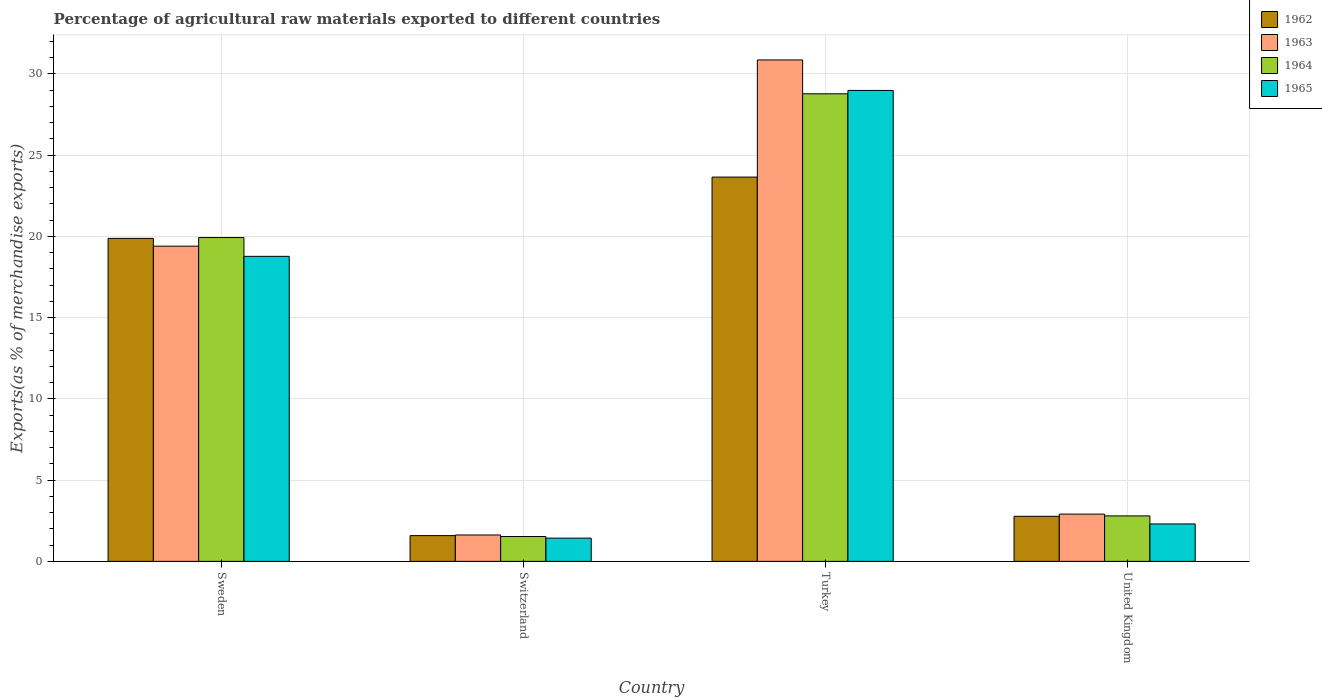How many groups of bars are there?
Ensure brevity in your answer.  4. What is the label of the 2nd group of bars from the left?
Offer a very short reply. Switzerland. What is the percentage of exports to different countries in 1964 in Switzerland?
Ensure brevity in your answer.  1.53. Across all countries, what is the maximum percentage of exports to different countries in 1965?
Provide a succinct answer. 28.99. Across all countries, what is the minimum percentage of exports to different countries in 1965?
Your answer should be compact. 1.43. In which country was the percentage of exports to different countries in 1964 minimum?
Your answer should be very brief. Switzerland. What is the total percentage of exports to different countries in 1962 in the graph?
Give a very brief answer. 47.89. What is the difference between the percentage of exports to different countries in 1963 in Sweden and that in Switzerland?
Ensure brevity in your answer.  17.78. What is the difference between the percentage of exports to different countries in 1965 in Turkey and the percentage of exports to different countries in 1962 in United Kingdom?
Give a very brief answer. 26.21. What is the average percentage of exports to different countries in 1964 per country?
Make the answer very short. 13.26. What is the difference between the percentage of exports to different countries of/in 1963 and percentage of exports to different countries of/in 1964 in Switzerland?
Provide a short and direct response. 0.1. In how many countries, is the percentage of exports to different countries in 1963 greater than 26 %?
Your answer should be compact. 1. What is the ratio of the percentage of exports to different countries in 1963 in Sweden to that in United Kingdom?
Offer a very short reply. 6.67. Is the percentage of exports to different countries in 1964 in Switzerland less than that in United Kingdom?
Ensure brevity in your answer.  Yes. Is the difference between the percentage of exports to different countries in 1963 in Sweden and United Kingdom greater than the difference between the percentage of exports to different countries in 1964 in Sweden and United Kingdom?
Offer a very short reply. No. What is the difference between the highest and the second highest percentage of exports to different countries in 1964?
Keep it short and to the point. -17.13. What is the difference between the highest and the lowest percentage of exports to different countries in 1962?
Keep it short and to the point. 22.07. In how many countries, is the percentage of exports to different countries in 1963 greater than the average percentage of exports to different countries in 1963 taken over all countries?
Your answer should be compact. 2. What does the 4th bar from the left in Turkey represents?
Provide a succinct answer. 1965. Are all the bars in the graph horizontal?
Offer a terse response. No. What is the difference between two consecutive major ticks on the Y-axis?
Give a very brief answer. 5. Are the values on the major ticks of Y-axis written in scientific E-notation?
Your answer should be very brief. No. Does the graph contain grids?
Provide a short and direct response. Yes. Where does the legend appear in the graph?
Your response must be concise. Top right. What is the title of the graph?
Offer a very short reply. Percentage of agricultural raw materials exported to different countries. Does "1964" appear as one of the legend labels in the graph?
Provide a short and direct response. Yes. What is the label or title of the Y-axis?
Offer a very short reply. Exports(as % of merchandise exports). What is the Exports(as % of merchandise exports) in 1962 in Sweden?
Keep it short and to the point. 19.88. What is the Exports(as % of merchandise exports) of 1963 in Sweden?
Keep it short and to the point. 19.4. What is the Exports(as % of merchandise exports) in 1964 in Sweden?
Your answer should be compact. 19.93. What is the Exports(as % of merchandise exports) in 1965 in Sweden?
Your response must be concise. 18.78. What is the Exports(as % of merchandise exports) in 1962 in Switzerland?
Your response must be concise. 1.58. What is the Exports(as % of merchandise exports) in 1963 in Switzerland?
Offer a very short reply. 1.62. What is the Exports(as % of merchandise exports) of 1964 in Switzerland?
Keep it short and to the point. 1.53. What is the Exports(as % of merchandise exports) in 1965 in Switzerland?
Provide a short and direct response. 1.43. What is the Exports(as % of merchandise exports) in 1962 in Turkey?
Keep it short and to the point. 23.65. What is the Exports(as % of merchandise exports) of 1963 in Turkey?
Provide a succinct answer. 30.86. What is the Exports(as % of merchandise exports) in 1964 in Turkey?
Give a very brief answer. 28.78. What is the Exports(as % of merchandise exports) of 1965 in Turkey?
Give a very brief answer. 28.99. What is the Exports(as % of merchandise exports) in 1962 in United Kingdom?
Offer a terse response. 2.77. What is the Exports(as % of merchandise exports) in 1963 in United Kingdom?
Offer a terse response. 2.91. What is the Exports(as % of merchandise exports) of 1964 in United Kingdom?
Make the answer very short. 2.8. What is the Exports(as % of merchandise exports) of 1965 in United Kingdom?
Make the answer very short. 2.3. Across all countries, what is the maximum Exports(as % of merchandise exports) in 1962?
Offer a terse response. 23.65. Across all countries, what is the maximum Exports(as % of merchandise exports) of 1963?
Make the answer very short. 30.86. Across all countries, what is the maximum Exports(as % of merchandise exports) of 1964?
Your answer should be compact. 28.78. Across all countries, what is the maximum Exports(as % of merchandise exports) in 1965?
Make the answer very short. 28.99. Across all countries, what is the minimum Exports(as % of merchandise exports) in 1962?
Offer a very short reply. 1.58. Across all countries, what is the minimum Exports(as % of merchandise exports) in 1963?
Provide a short and direct response. 1.62. Across all countries, what is the minimum Exports(as % of merchandise exports) in 1964?
Your response must be concise. 1.53. Across all countries, what is the minimum Exports(as % of merchandise exports) of 1965?
Make the answer very short. 1.43. What is the total Exports(as % of merchandise exports) of 1962 in the graph?
Ensure brevity in your answer.  47.89. What is the total Exports(as % of merchandise exports) of 1963 in the graph?
Provide a short and direct response. 54.8. What is the total Exports(as % of merchandise exports) in 1964 in the graph?
Your answer should be compact. 53.04. What is the total Exports(as % of merchandise exports) of 1965 in the graph?
Your response must be concise. 51.5. What is the difference between the Exports(as % of merchandise exports) in 1962 in Sweden and that in Switzerland?
Your response must be concise. 18.3. What is the difference between the Exports(as % of merchandise exports) in 1963 in Sweden and that in Switzerland?
Offer a terse response. 17.78. What is the difference between the Exports(as % of merchandise exports) of 1964 in Sweden and that in Switzerland?
Provide a succinct answer. 18.4. What is the difference between the Exports(as % of merchandise exports) in 1965 in Sweden and that in Switzerland?
Offer a terse response. 17.35. What is the difference between the Exports(as % of merchandise exports) in 1962 in Sweden and that in Turkey?
Your answer should be compact. -3.77. What is the difference between the Exports(as % of merchandise exports) of 1963 in Sweden and that in Turkey?
Make the answer very short. -11.46. What is the difference between the Exports(as % of merchandise exports) of 1964 in Sweden and that in Turkey?
Offer a very short reply. -8.85. What is the difference between the Exports(as % of merchandise exports) of 1965 in Sweden and that in Turkey?
Keep it short and to the point. -10.21. What is the difference between the Exports(as % of merchandise exports) in 1962 in Sweden and that in United Kingdom?
Ensure brevity in your answer.  17.11. What is the difference between the Exports(as % of merchandise exports) of 1963 in Sweden and that in United Kingdom?
Your answer should be very brief. 16.49. What is the difference between the Exports(as % of merchandise exports) in 1964 in Sweden and that in United Kingdom?
Offer a terse response. 17.13. What is the difference between the Exports(as % of merchandise exports) in 1965 in Sweden and that in United Kingdom?
Offer a terse response. 16.47. What is the difference between the Exports(as % of merchandise exports) in 1962 in Switzerland and that in Turkey?
Your response must be concise. -22.07. What is the difference between the Exports(as % of merchandise exports) in 1963 in Switzerland and that in Turkey?
Your response must be concise. -29.24. What is the difference between the Exports(as % of merchandise exports) of 1964 in Switzerland and that in Turkey?
Offer a very short reply. -27.25. What is the difference between the Exports(as % of merchandise exports) of 1965 in Switzerland and that in Turkey?
Offer a very short reply. -27.56. What is the difference between the Exports(as % of merchandise exports) in 1962 in Switzerland and that in United Kingdom?
Keep it short and to the point. -1.19. What is the difference between the Exports(as % of merchandise exports) of 1963 in Switzerland and that in United Kingdom?
Offer a terse response. -1.28. What is the difference between the Exports(as % of merchandise exports) of 1964 in Switzerland and that in United Kingdom?
Keep it short and to the point. -1.27. What is the difference between the Exports(as % of merchandise exports) in 1965 in Switzerland and that in United Kingdom?
Make the answer very short. -0.87. What is the difference between the Exports(as % of merchandise exports) of 1962 in Turkey and that in United Kingdom?
Keep it short and to the point. 20.88. What is the difference between the Exports(as % of merchandise exports) in 1963 in Turkey and that in United Kingdom?
Your response must be concise. 27.96. What is the difference between the Exports(as % of merchandise exports) in 1964 in Turkey and that in United Kingdom?
Your response must be concise. 25.98. What is the difference between the Exports(as % of merchandise exports) of 1965 in Turkey and that in United Kingdom?
Keep it short and to the point. 26.68. What is the difference between the Exports(as % of merchandise exports) of 1962 in Sweden and the Exports(as % of merchandise exports) of 1963 in Switzerland?
Give a very brief answer. 18.26. What is the difference between the Exports(as % of merchandise exports) in 1962 in Sweden and the Exports(as % of merchandise exports) in 1964 in Switzerland?
Make the answer very short. 18.35. What is the difference between the Exports(as % of merchandise exports) in 1962 in Sweden and the Exports(as % of merchandise exports) in 1965 in Switzerland?
Your response must be concise. 18.45. What is the difference between the Exports(as % of merchandise exports) of 1963 in Sweden and the Exports(as % of merchandise exports) of 1964 in Switzerland?
Keep it short and to the point. 17.87. What is the difference between the Exports(as % of merchandise exports) in 1963 in Sweden and the Exports(as % of merchandise exports) in 1965 in Switzerland?
Ensure brevity in your answer.  17.97. What is the difference between the Exports(as % of merchandise exports) in 1964 in Sweden and the Exports(as % of merchandise exports) in 1965 in Switzerland?
Make the answer very short. 18.5. What is the difference between the Exports(as % of merchandise exports) of 1962 in Sweden and the Exports(as % of merchandise exports) of 1963 in Turkey?
Offer a very short reply. -10.98. What is the difference between the Exports(as % of merchandise exports) in 1962 in Sweden and the Exports(as % of merchandise exports) in 1964 in Turkey?
Make the answer very short. -8.9. What is the difference between the Exports(as % of merchandise exports) of 1962 in Sweden and the Exports(as % of merchandise exports) of 1965 in Turkey?
Ensure brevity in your answer.  -9.11. What is the difference between the Exports(as % of merchandise exports) of 1963 in Sweden and the Exports(as % of merchandise exports) of 1964 in Turkey?
Give a very brief answer. -9.38. What is the difference between the Exports(as % of merchandise exports) of 1963 in Sweden and the Exports(as % of merchandise exports) of 1965 in Turkey?
Your answer should be compact. -9.59. What is the difference between the Exports(as % of merchandise exports) of 1964 in Sweden and the Exports(as % of merchandise exports) of 1965 in Turkey?
Offer a terse response. -9.06. What is the difference between the Exports(as % of merchandise exports) in 1962 in Sweden and the Exports(as % of merchandise exports) in 1963 in United Kingdom?
Your response must be concise. 16.97. What is the difference between the Exports(as % of merchandise exports) of 1962 in Sweden and the Exports(as % of merchandise exports) of 1964 in United Kingdom?
Give a very brief answer. 17.08. What is the difference between the Exports(as % of merchandise exports) of 1962 in Sweden and the Exports(as % of merchandise exports) of 1965 in United Kingdom?
Ensure brevity in your answer.  17.58. What is the difference between the Exports(as % of merchandise exports) of 1963 in Sweden and the Exports(as % of merchandise exports) of 1964 in United Kingdom?
Offer a very short reply. 16.6. What is the difference between the Exports(as % of merchandise exports) in 1963 in Sweden and the Exports(as % of merchandise exports) in 1965 in United Kingdom?
Offer a terse response. 17.1. What is the difference between the Exports(as % of merchandise exports) of 1964 in Sweden and the Exports(as % of merchandise exports) of 1965 in United Kingdom?
Make the answer very short. 17.63. What is the difference between the Exports(as % of merchandise exports) in 1962 in Switzerland and the Exports(as % of merchandise exports) in 1963 in Turkey?
Your response must be concise. -29.28. What is the difference between the Exports(as % of merchandise exports) in 1962 in Switzerland and the Exports(as % of merchandise exports) in 1964 in Turkey?
Provide a succinct answer. -27.2. What is the difference between the Exports(as % of merchandise exports) in 1962 in Switzerland and the Exports(as % of merchandise exports) in 1965 in Turkey?
Your answer should be compact. -27.4. What is the difference between the Exports(as % of merchandise exports) in 1963 in Switzerland and the Exports(as % of merchandise exports) in 1964 in Turkey?
Ensure brevity in your answer.  -27.16. What is the difference between the Exports(as % of merchandise exports) in 1963 in Switzerland and the Exports(as % of merchandise exports) in 1965 in Turkey?
Ensure brevity in your answer.  -27.36. What is the difference between the Exports(as % of merchandise exports) of 1964 in Switzerland and the Exports(as % of merchandise exports) of 1965 in Turkey?
Keep it short and to the point. -27.46. What is the difference between the Exports(as % of merchandise exports) of 1962 in Switzerland and the Exports(as % of merchandise exports) of 1963 in United Kingdom?
Ensure brevity in your answer.  -1.32. What is the difference between the Exports(as % of merchandise exports) of 1962 in Switzerland and the Exports(as % of merchandise exports) of 1964 in United Kingdom?
Keep it short and to the point. -1.21. What is the difference between the Exports(as % of merchandise exports) of 1962 in Switzerland and the Exports(as % of merchandise exports) of 1965 in United Kingdom?
Make the answer very short. -0.72. What is the difference between the Exports(as % of merchandise exports) in 1963 in Switzerland and the Exports(as % of merchandise exports) in 1964 in United Kingdom?
Provide a short and direct response. -1.17. What is the difference between the Exports(as % of merchandise exports) of 1963 in Switzerland and the Exports(as % of merchandise exports) of 1965 in United Kingdom?
Keep it short and to the point. -0.68. What is the difference between the Exports(as % of merchandise exports) in 1964 in Switzerland and the Exports(as % of merchandise exports) in 1965 in United Kingdom?
Ensure brevity in your answer.  -0.78. What is the difference between the Exports(as % of merchandise exports) in 1962 in Turkey and the Exports(as % of merchandise exports) in 1963 in United Kingdom?
Your answer should be compact. 20.75. What is the difference between the Exports(as % of merchandise exports) of 1962 in Turkey and the Exports(as % of merchandise exports) of 1964 in United Kingdom?
Your answer should be very brief. 20.86. What is the difference between the Exports(as % of merchandise exports) in 1962 in Turkey and the Exports(as % of merchandise exports) in 1965 in United Kingdom?
Your answer should be very brief. 21.35. What is the difference between the Exports(as % of merchandise exports) in 1963 in Turkey and the Exports(as % of merchandise exports) in 1964 in United Kingdom?
Your answer should be very brief. 28.07. What is the difference between the Exports(as % of merchandise exports) of 1963 in Turkey and the Exports(as % of merchandise exports) of 1965 in United Kingdom?
Offer a terse response. 28.56. What is the difference between the Exports(as % of merchandise exports) of 1964 in Turkey and the Exports(as % of merchandise exports) of 1965 in United Kingdom?
Offer a terse response. 26.48. What is the average Exports(as % of merchandise exports) in 1962 per country?
Offer a terse response. 11.97. What is the average Exports(as % of merchandise exports) in 1963 per country?
Your answer should be compact. 13.7. What is the average Exports(as % of merchandise exports) of 1964 per country?
Give a very brief answer. 13.26. What is the average Exports(as % of merchandise exports) of 1965 per country?
Provide a short and direct response. 12.87. What is the difference between the Exports(as % of merchandise exports) of 1962 and Exports(as % of merchandise exports) of 1963 in Sweden?
Provide a succinct answer. 0.48. What is the difference between the Exports(as % of merchandise exports) in 1962 and Exports(as % of merchandise exports) in 1964 in Sweden?
Your answer should be very brief. -0.05. What is the difference between the Exports(as % of merchandise exports) of 1962 and Exports(as % of merchandise exports) of 1965 in Sweden?
Your answer should be very brief. 1.1. What is the difference between the Exports(as % of merchandise exports) in 1963 and Exports(as % of merchandise exports) in 1964 in Sweden?
Ensure brevity in your answer.  -0.53. What is the difference between the Exports(as % of merchandise exports) of 1963 and Exports(as % of merchandise exports) of 1965 in Sweden?
Keep it short and to the point. 0.63. What is the difference between the Exports(as % of merchandise exports) in 1964 and Exports(as % of merchandise exports) in 1965 in Sweden?
Your response must be concise. 1.16. What is the difference between the Exports(as % of merchandise exports) in 1962 and Exports(as % of merchandise exports) in 1963 in Switzerland?
Give a very brief answer. -0.04. What is the difference between the Exports(as % of merchandise exports) of 1962 and Exports(as % of merchandise exports) of 1964 in Switzerland?
Keep it short and to the point. 0.06. What is the difference between the Exports(as % of merchandise exports) in 1962 and Exports(as % of merchandise exports) in 1965 in Switzerland?
Your response must be concise. 0.15. What is the difference between the Exports(as % of merchandise exports) of 1963 and Exports(as % of merchandise exports) of 1964 in Switzerland?
Ensure brevity in your answer.  0.1. What is the difference between the Exports(as % of merchandise exports) in 1963 and Exports(as % of merchandise exports) in 1965 in Switzerland?
Give a very brief answer. 0.19. What is the difference between the Exports(as % of merchandise exports) in 1964 and Exports(as % of merchandise exports) in 1965 in Switzerland?
Your response must be concise. 0.1. What is the difference between the Exports(as % of merchandise exports) in 1962 and Exports(as % of merchandise exports) in 1963 in Turkey?
Your answer should be very brief. -7.21. What is the difference between the Exports(as % of merchandise exports) of 1962 and Exports(as % of merchandise exports) of 1964 in Turkey?
Provide a short and direct response. -5.13. What is the difference between the Exports(as % of merchandise exports) in 1962 and Exports(as % of merchandise exports) in 1965 in Turkey?
Ensure brevity in your answer.  -5.33. What is the difference between the Exports(as % of merchandise exports) of 1963 and Exports(as % of merchandise exports) of 1964 in Turkey?
Provide a short and direct response. 2.08. What is the difference between the Exports(as % of merchandise exports) of 1963 and Exports(as % of merchandise exports) of 1965 in Turkey?
Provide a succinct answer. 1.88. What is the difference between the Exports(as % of merchandise exports) in 1964 and Exports(as % of merchandise exports) in 1965 in Turkey?
Offer a very short reply. -0.21. What is the difference between the Exports(as % of merchandise exports) in 1962 and Exports(as % of merchandise exports) in 1963 in United Kingdom?
Your response must be concise. -0.13. What is the difference between the Exports(as % of merchandise exports) of 1962 and Exports(as % of merchandise exports) of 1964 in United Kingdom?
Keep it short and to the point. -0.02. What is the difference between the Exports(as % of merchandise exports) of 1962 and Exports(as % of merchandise exports) of 1965 in United Kingdom?
Give a very brief answer. 0.47. What is the difference between the Exports(as % of merchandise exports) of 1963 and Exports(as % of merchandise exports) of 1964 in United Kingdom?
Your answer should be very brief. 0.11. What is the difference between the Exports(as % of merchandise exports) in 1963 and Exports(as % of merchandise exports) in 1965 in United Kingdom?
Provide a short and direct response. 0.6. What is the difference between the Exports(as % of merchandise exports) of 1964 and Exports(as % of merchandise exports) of 1965 in United Kingdom?
Provide a succinct answer. 0.49. What is the ratio of the Exports(as % of merchandise exports) of 1962 in Sweden to that in Switzerland?
Offer a very short reply. 12.55. What is the ratio of the Exports(as % of merchandise exports) in 1963 in Sweden to that in Switzerland?
Keep it short and to the point. 11.95. What is the ratio of the Exports(as % of merchandise exports) in 1964 in Sweden to that in Switzerland?
Ensure brevity in your answer.  13.04. What is the ratio of the Exports(as % of merchandise exports) of 1965 in Sweden to that in Switzerland?
Keep it short and to the point. 13.13. What is the ratio of the Exports(as % of merchandise exports) of 1962 in Sweden to that in Turkey?
Offer a very short reply. 0.84. What is the ratio of the Exports(as % of merchandise exports) in 1963 in Sweden to that in Turkey?
Your response must be concise. 0.63. What is the ratio of the Exports(as % of merchandise exports) of 1964 in Sweden to that in Turkey?
Provide a succinct answer. 0.69. What is the ratio of the Exports(as % of merchandise exports) of 1965 in Sweden to that in Turkey?
Your response must be concise. 0.65. What is the ratio of the Exports(as % of merchandise exports) of 1962 in Sweden to that in United Kingdom?
Offer a terse response. 7.17. What is the ratio of the Exports(as % of merchandise exports) in 1963 in Sweden to that in United Kingdom?
Keep it short and to the point. 6.67. What is the ratio of the Exports(as % of merchandise exports) of 1964 in Sweden to that in United Kingdom?
Your answer should be compact. 7.12. What is the ratio of the Exports(as % of merchandise exports) of 1965 in Sweden to that in United Kingdom?
Ensure brevity in your answer.  8.15. What is the ratio of the Exports(as % of merchandise exports) of 1962 in Switzerland to that in Turkey?
Provide a short and direct response. 0.07. What is the ratio of the Exports(as % of merchandise exports) in 1963 in Switzerland to that in Turkey?
Ensure brevity in your answer.  0.05. What is the ratio of the Exports(as % of merchandise exports) of 1964 in Switzerland to that in Turkey?
Offer a terse response. 0.05. What is the ratio of the Exports(as % of merchandise exports) of 1965 in Switzerland to that in Turkey?
Ensure brevity in your answer.  0.05. What is the ratio of the Exports(as % of merchandise exports) in 1962 in Switzerland to that in United Kingdom?
Your response must be concise. 0.57. What is the ratio of the Exports(as % of merchandise exports) in 1963 in Switzerland to that in United Kingdom?
Ensure brevity in your answer.  0.56. What is the ratio of the Exports(as % of merchandise exports) of 1964 in Switzerland to that in United Kingdom?
Ensure brevity in your answer.  0.55. What is the ratio of the Exports(as % of merchandise exports) of 1965 in Switzerland to that in United Kingdom?
Your answer should be very brief. 0.62. What is the ratio of the Exports(as % of merchandise exports) in 1962 in Turkey to that in United Kingdom?
Your answer should be very brief. 8.53. What is the ratio of the Exports(as % of merchandise exports) of 1963 in Turkey to that in United Kingdom?
Your answer should be very brief. 10.61. What is the ratio of the Exports(as % of merchandise exports) in 1964 in Turkey to that in United Kingdom?
Your answer should be compact. 10.28. What is the ratio of the Exports(as % of merchandise exports) in 1965 in Turkey to that in United Kingdom?
Ensure brevity in your answer.  12.58. What is the difference between the highest and the second highest Exports(as % of merchandise exports) in 1962?
Provide a short and direct response. 3.77. What is the difference between the highest and the second highest Exports(as % of merchandise exports) in 1963?
Your answer should be compact. 11.46. What is the difference between the highest and the second highest Exports(as % of merchandise exports) of 1964?
Provide a succinct answer. 8.85. What is the difference between the highest and the second highest Exports(as % of merchandise exports) in 1965?
Offer a terse response. 10.21. What is the difference between the highest and the lowest Exports(as % of merchandise exports) in 1962?
Your answer should be very brief. 22.07. What is the difference between the highest and the lowest Exports(as % of merchandise exports) in 1963?
Your answer should be compact. 29.24. What is the difference between the highest and the lowest Exports(as % of merchandise exports) of 1964?
Offer a terse response. 27.25. What is the difference between the highest and the lowest Exports(as % of merchandise exports) in 1965?
Provide a short and direct response. 27.56. 